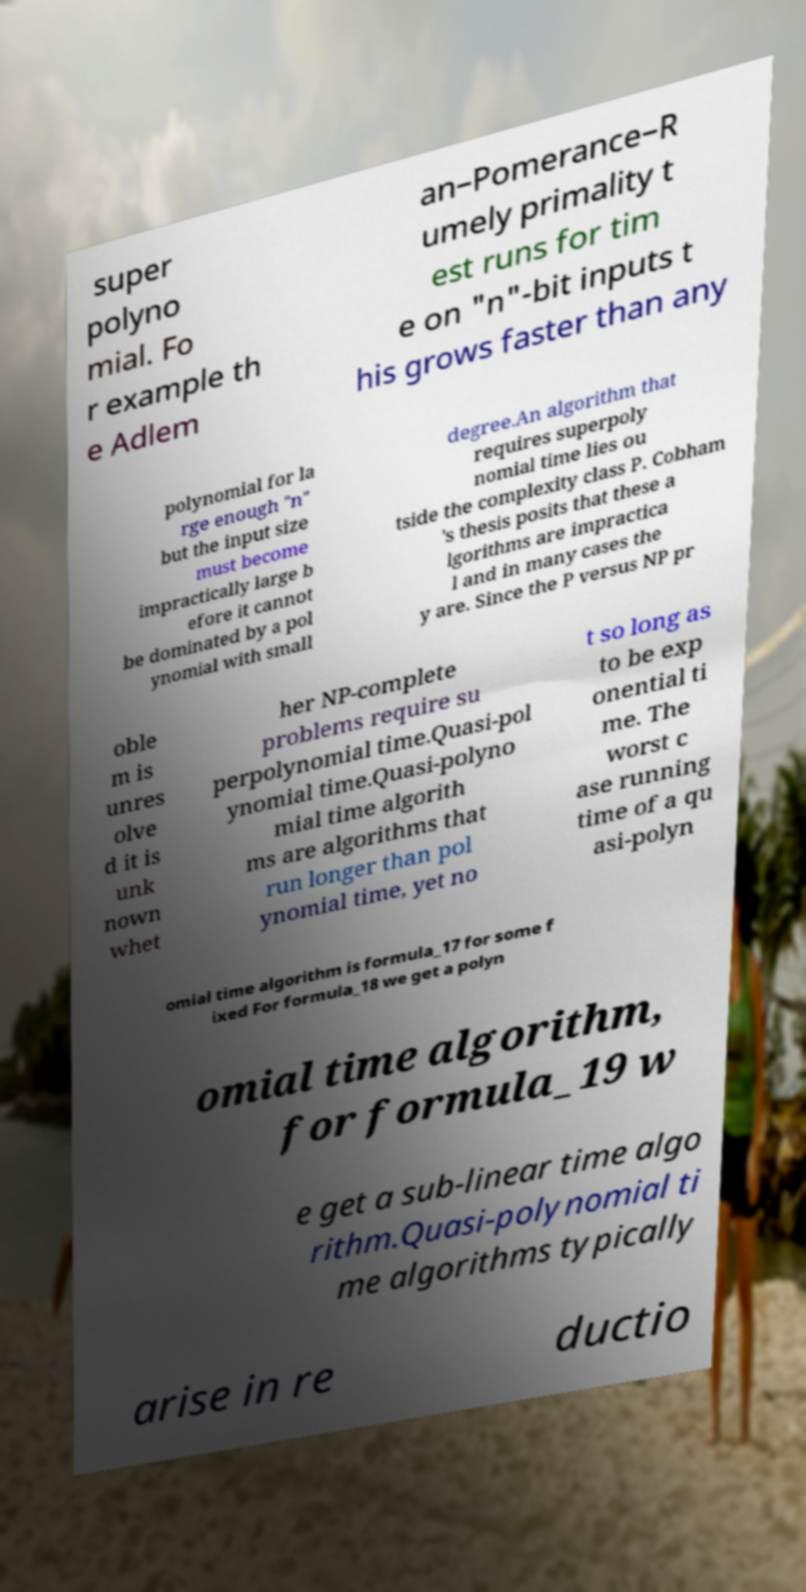What messages or text are displayed in this image? I need them in a readable, typed format. super polyno mial. Fo r example th e Adlem an–Pomerance–R umely primality t est runs for tim e on "n"-bit inputs t his grows faster than any polynomial for la rge enough "n" but the input size must become impractically large b efore it cannot be dominated by a pol ynomial with small degree.An algorithm that requires superpoly nomial time lies ou tside the complexity class P. Cobham 's thesis posits that these a lgorithms are impractica l and in many cases the y are. Since the P versus NP pr oble m is unres olve d it is unk nown whet her NP-complete problems require su perpolynomial time.Quasi-pol ynomial time.Quasi-polyno mial time algorith ms are algorithms that run longer than pol ynomial time, yet no t so long as to be exp onential ti me. The worst c ase running time of a qu asi-polyn omial time algorithm is formula_17 for some f ixed For formula_18 we get a polyn omial time algorithm, for formula_19 w e get a sub-linear time algo rithm.Quasi-polynomial ti me algorithms typically arise in re ductio 